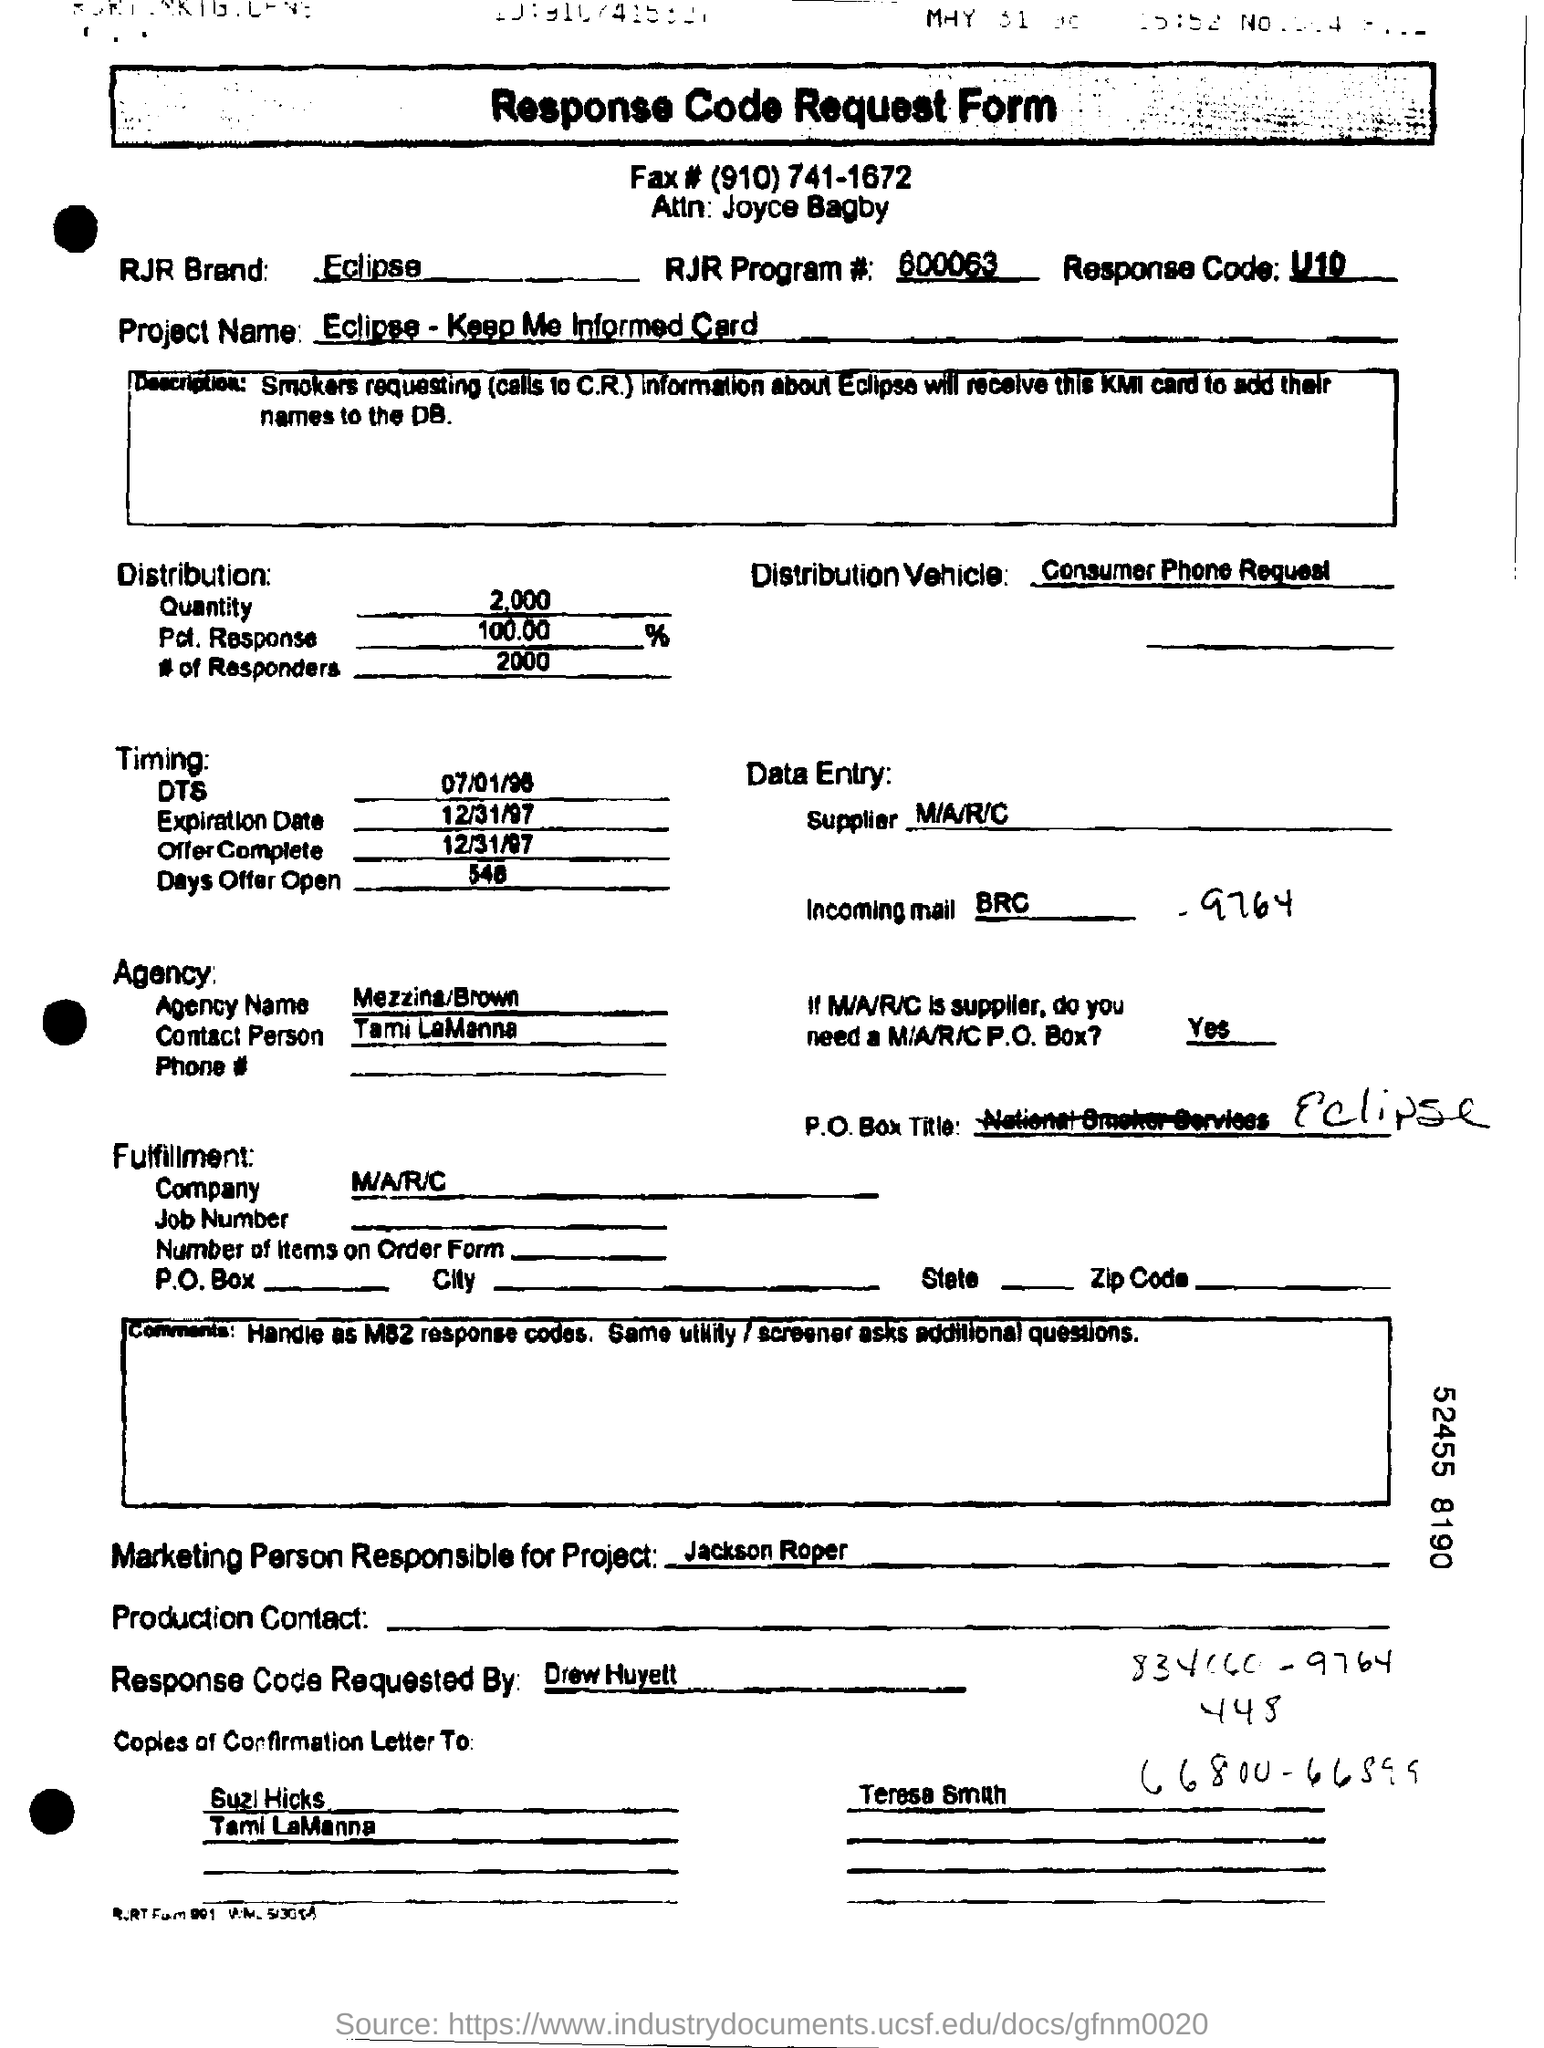Give some essential details in this illustration. The marketing person responsible for the project is Jackson Roper. The project name is "Eclipse" and the speaker will keep informed about the project. 